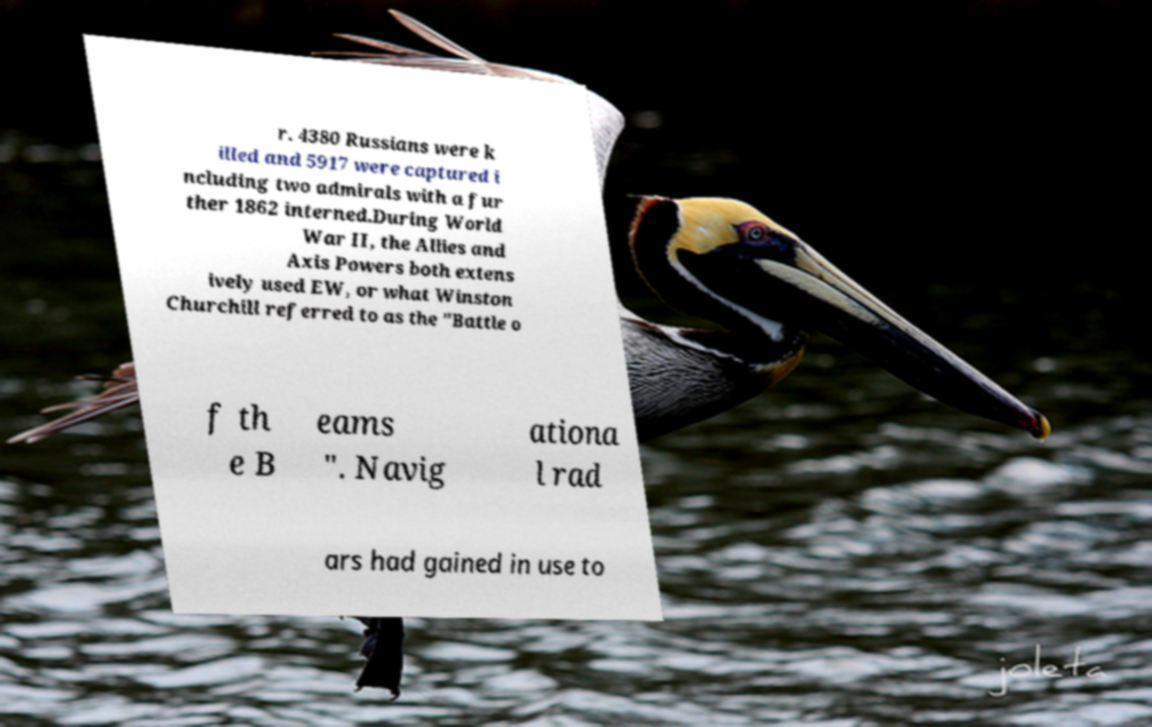For documentation purposes, I need the text within this image transcribed. Could you provide that? r. 4380 Russians were k illed and 5917 were captured i ncluding two admirals with a fur ther 1862 interned.During World War II, the Allies and Axis Powers both extens ively used EW, or what Winston Churchill referred to as the "Battle o f th e B eams ". Navig ationa l rad ars had gained in use to 